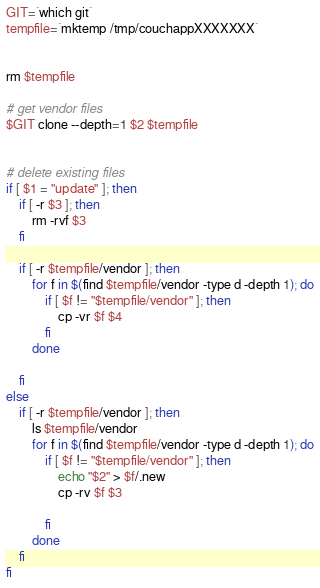<code> <loc_0><loc_0><loc_500><loc_500><_Bash_>GIT=`which git` 
tempfile=`mktemp /tmp/couchappXXXXXXX`


rm $tempfile

# get vendor files
$GIT clone --depth=1 $2 $tempfile


# delete existing files
if [ $1 = "update" ]; then
    if [ -r $3 ]; then
        rm -rvf $3
    fi
 
    if [ -r $tempfile/vendor ]; then
        for f in $(find $tempfile/vendor -type d -depth 1); do
            if [ $f != "$tempfile/vendor" ]; then
                cp -vr $f $4
            fi
        done
        
    fi
else
    if [ -r $tempfile/vendor ]; then
        ls $tempfile/vendor
        for f in $(find $tempfile/vendor -type d -depth 1); do
            if [ $f != "$tempfile/vendor" ]; then
                echo "$2" > $f/.new
                cp -rv $f $3
                
            fi
        done
    fi
fi</code> 